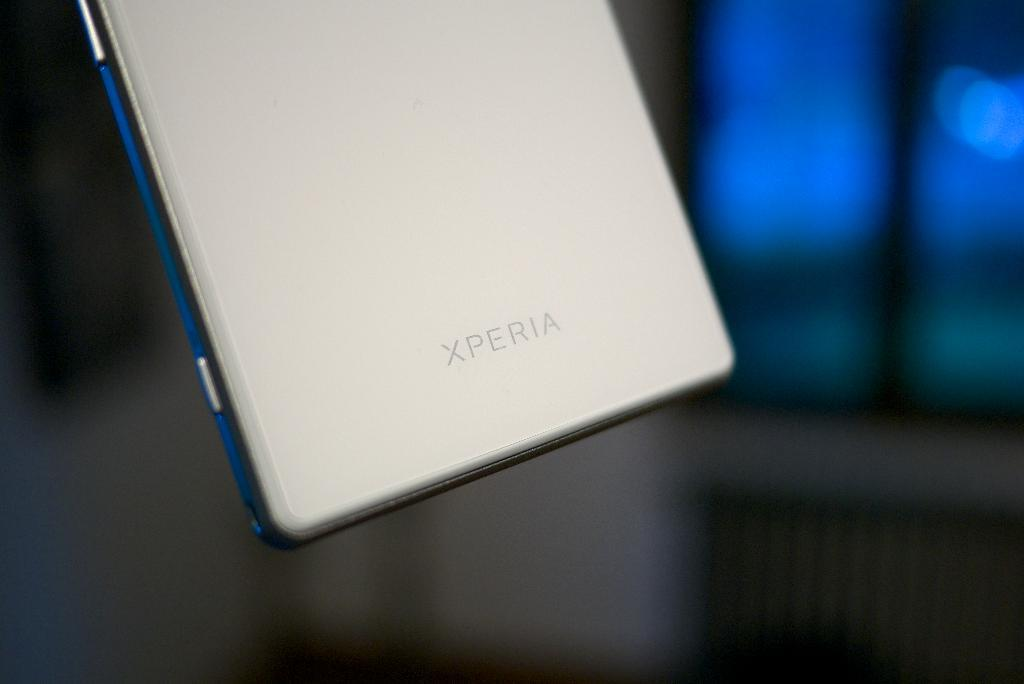<image>
Write a terse but informative summary of the picture. white xperia cellphone with blue side trim against a grey and blue background 